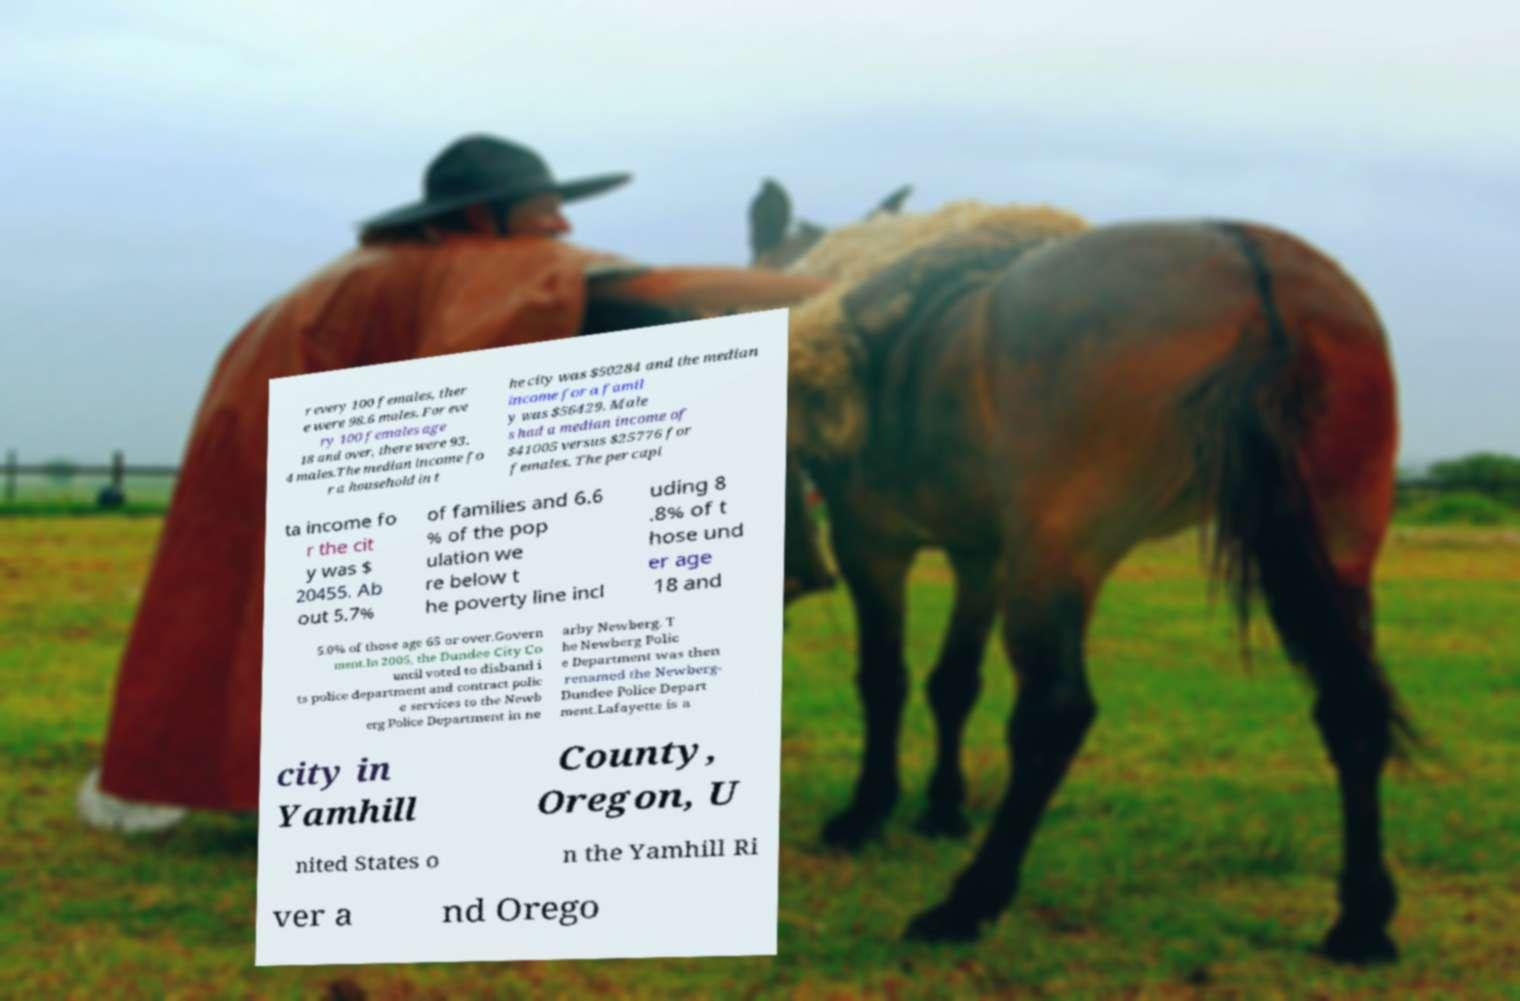There's text embedded in this image that I need extracted. Can you transcribe it verbatim? r every 100 females, ther e were 98.6 males. For eve ry 100 females age 18 and over, there were 93. 4 males.The median income fo r a household in t he city was $50284 and the median income for a famil y was $56429. Male s had a median income of $41005 versus $25776 for females. The per capi ta income fo r the cit y was $ 20455. Ab out 5.7% of families and 6.6 % of the pop ulation we re below t he poverty line incl uding 8 .8% of t hose und er age 18 and 5.0% of those age 65 or over.Govern ment.In 2005, the Dundee City Co uncil voted to disband i ts police department and contract polic e services to the Newb erg Police Department in ne arby Newberg. T he Newberg Polic e Department was then renamed the Newberg- Dundee Police Depart ment.Lafayette is a city in Yamhill County, Oregon, U nited States o n the Yamhill Ri ver a nd Orego 